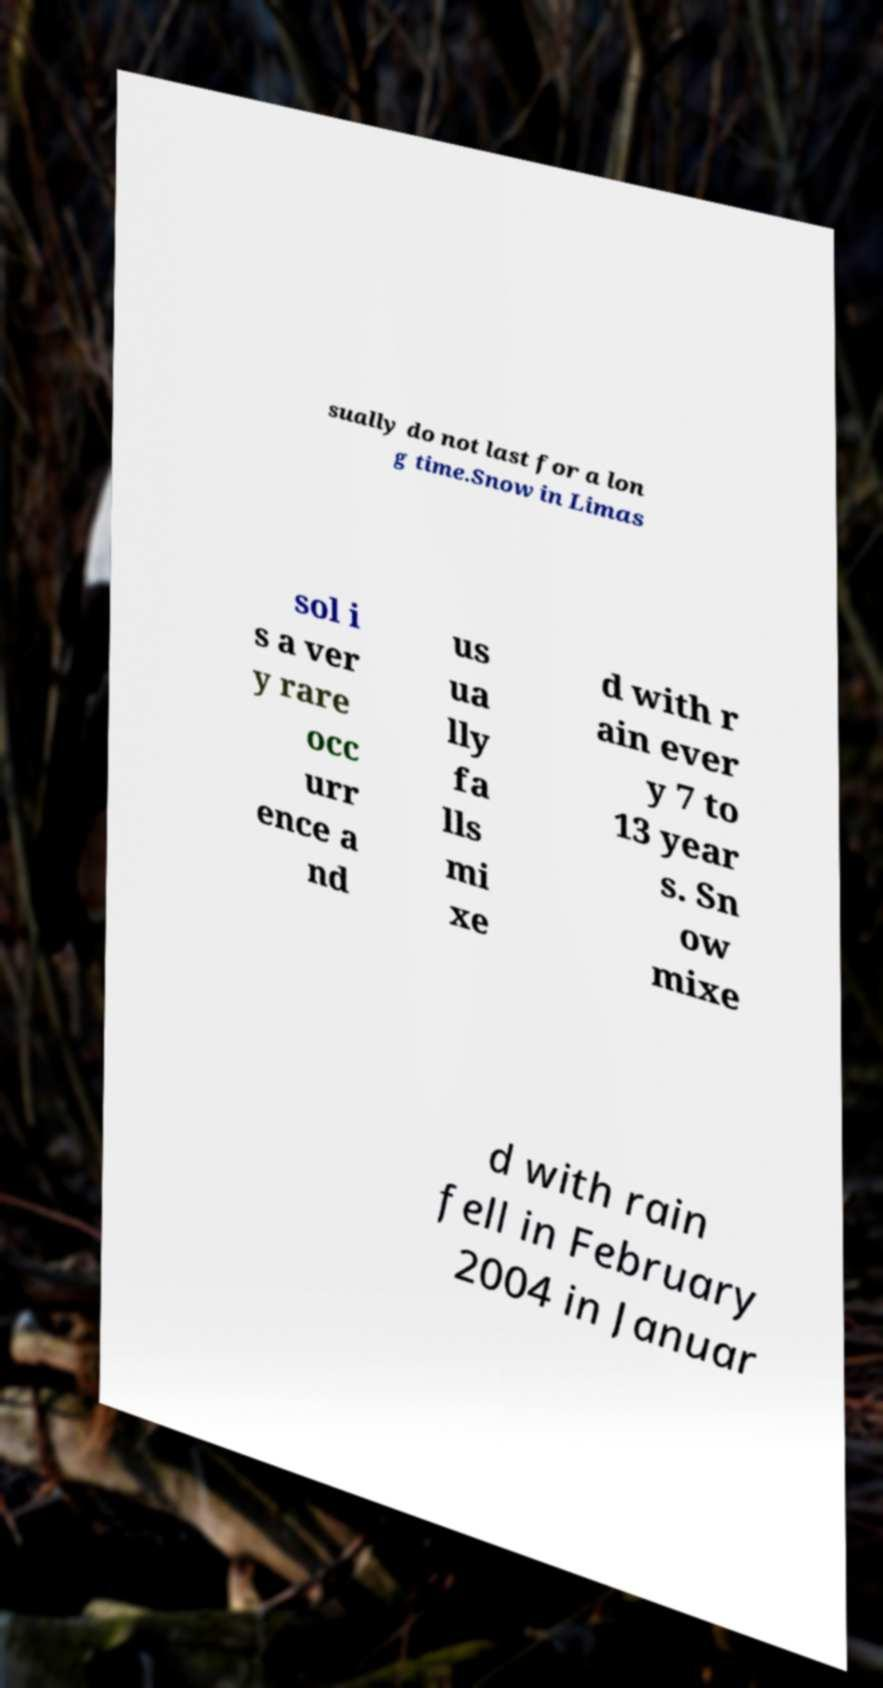Please read and relay the text visible in this image. What does it say? sually do not last for a lon g time.Snow in Limas sol i s a ver y rare occ urr ence a nd us ua lly fa lls mi xe d with r ain ever y 7 to 13 year s. Sn ow mixe d with rain fell in February 2004 in Januar 